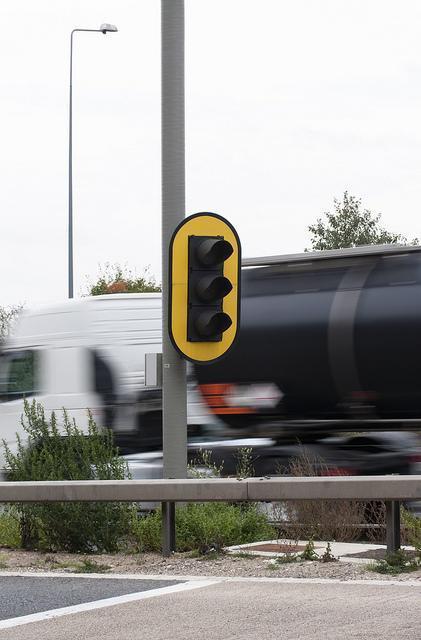How many street lights can be seen?
Give a very brief answer. 1. How many skateboards can be seen?
Give a very brief answer. 0. 